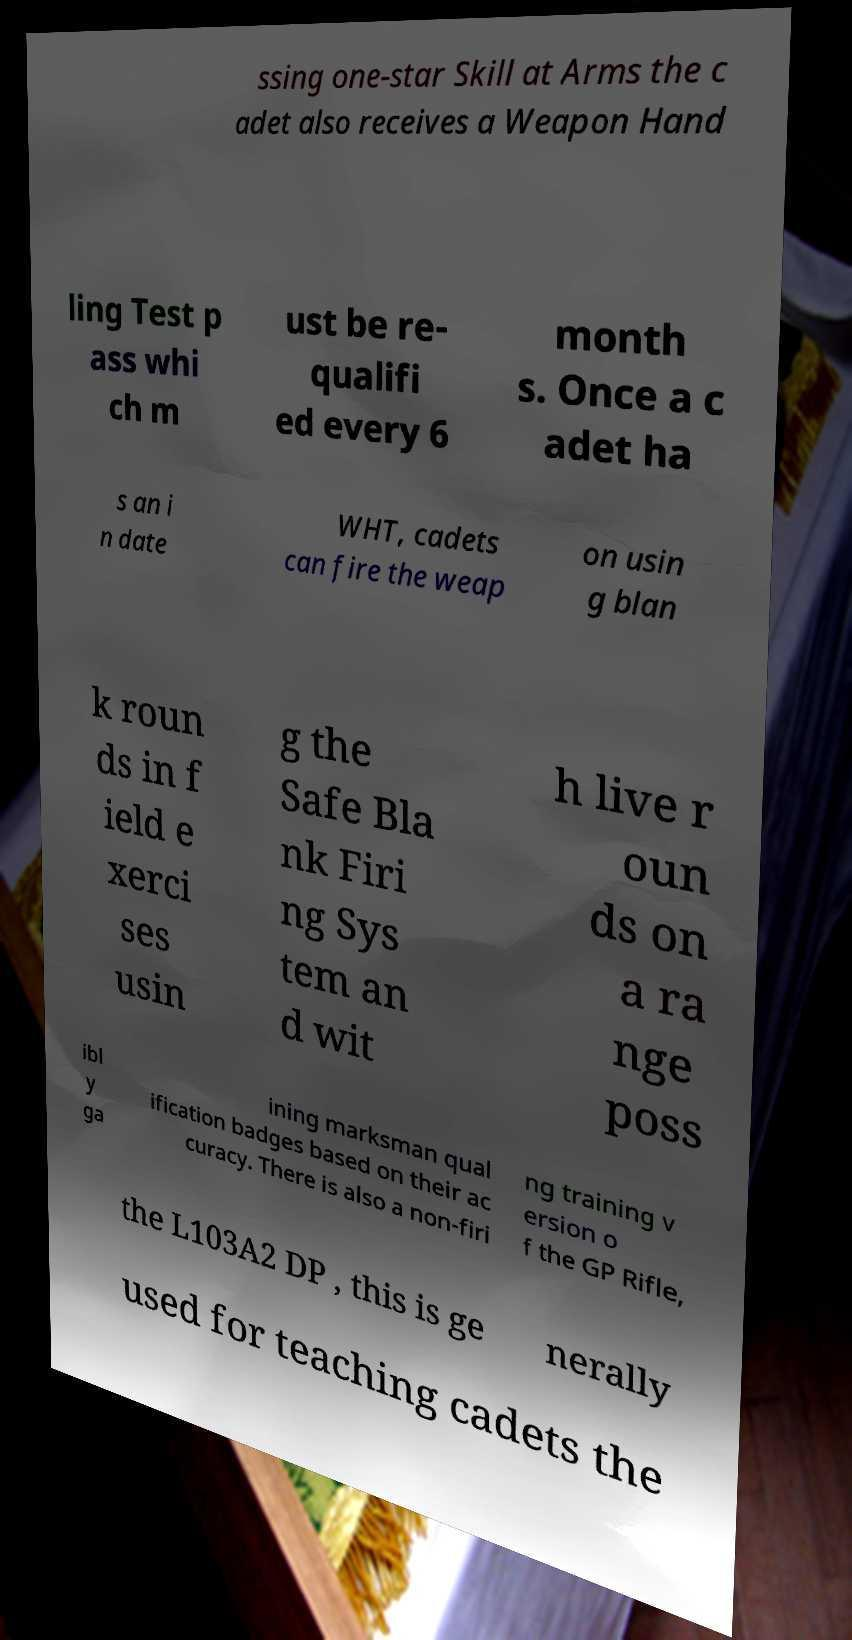Can you accurately transcribe the text from the provided image for me? ssing one-star Skill at Arms the c adet also receives a Weapon Hand ling Test p ass whi ch m ust be re- qualifi ed every 6 month s. Once a c adet ha s an i n date WHT, cadets can fire the weap on usin g blan k roun ds in f ield e xerci ses usin g the Safe Bla nk Firi ng Sys tem an d wit h live r oun ds on a ra nge poss ibl y ga ining marksman qual ification badges based on their ac curacy. There is also a non-firi ng training v ersion o f the GP Rifle, the L103A2 DP , this is ge nerally used for teaching cadets the 